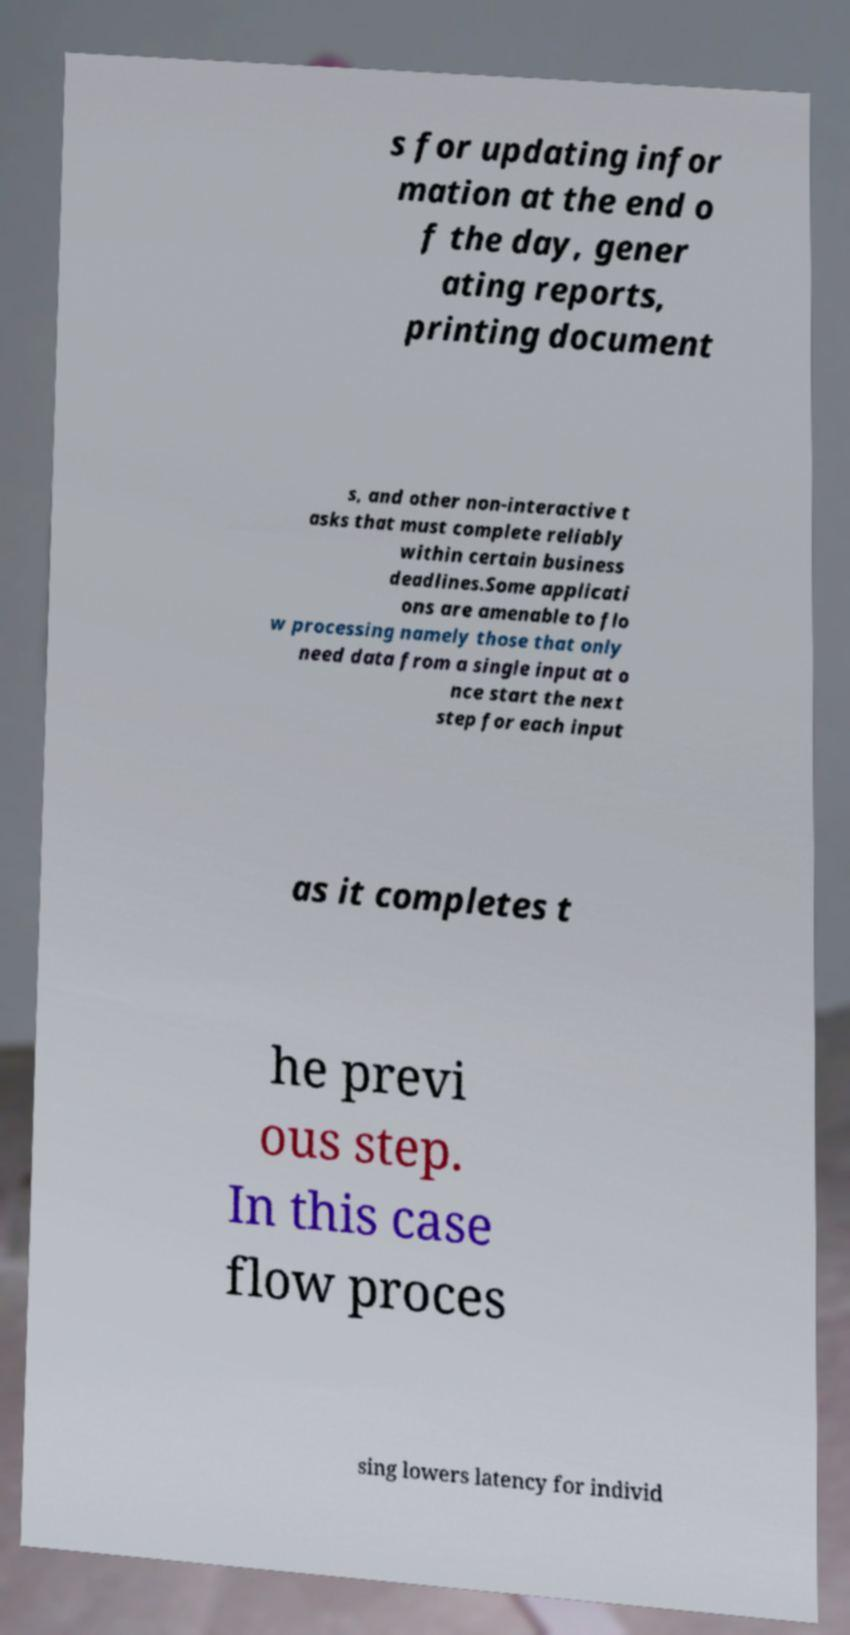Could you assist in decoding the text presented in this image and type it out clearly? s for updating infor mation at the end o f the day, gener ating reports, printing document s, and other non-interactive t asks that must complete reliably within certain business deadlines.Some applicati ons are amenable to flo w processing namely those that only need data from a single input at o nce start the next step for each input as it completes t he previ ous step. In this case flow proces sing lowers latency for individ 